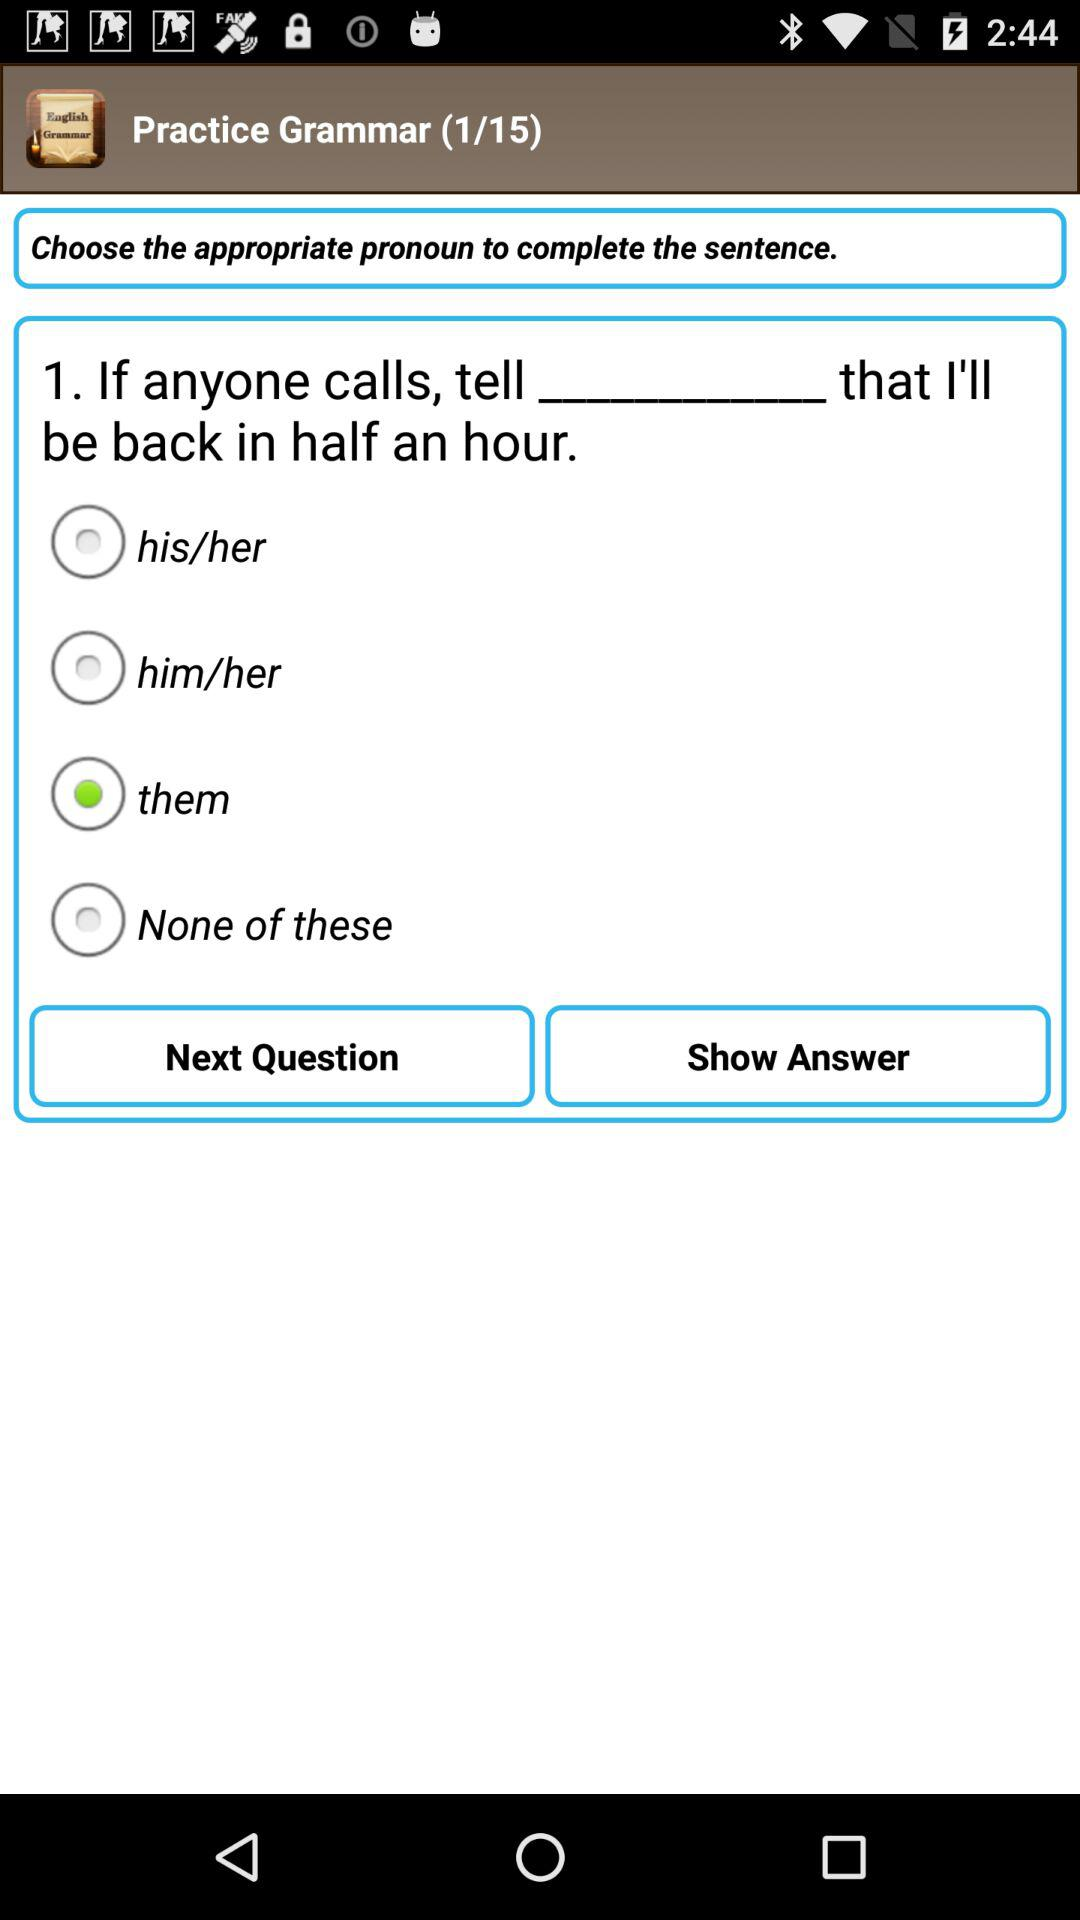Which is the selected option? The selected option is "them". 